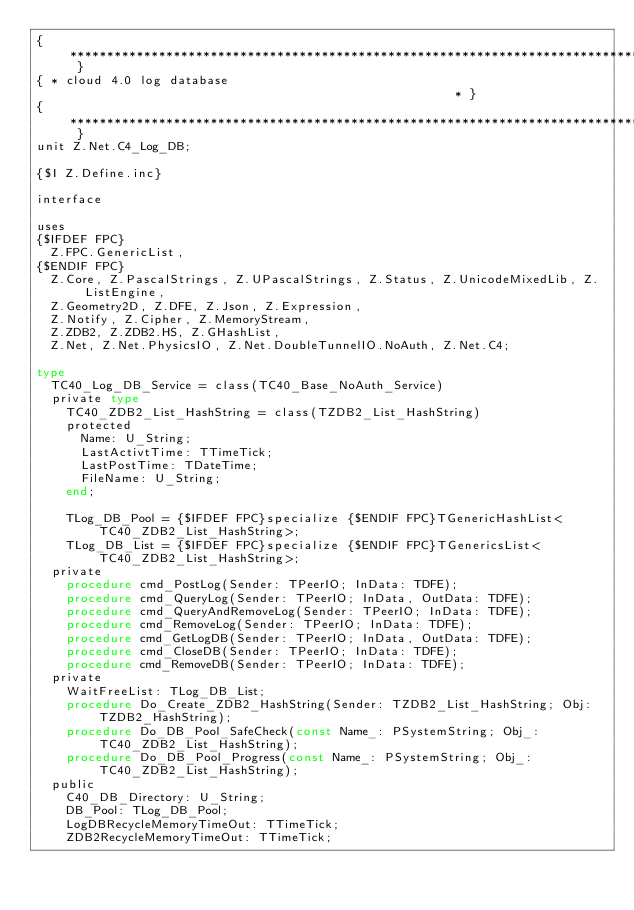Convert code to text. <code><loc_0><loc_0><loc_500><loc_500><_Pascal_>{ ****************************************************************************** }
{ * cloud 4.0 log database                                                     * }
{ ****************************************************************************** }
unit Z.Net.C4_Log_DB;

{$I Z.Define.inc}

interface

uses
{$IFDEF FPC}
  Z.FPC.GenericList,
{$ENDIF FPC}
  Z.Core, Z.PascalStrings, Z.UPascalStrings, Z.Status, Z.UnicodeMixedLib, Z.ListEngine,
  Z.Geometry2D, Z.DFE, Z.Json, Z.Expression,
  Z.Notify, Z.Cipher, Z.MemoryStream,
  Z.ZDB2, Z.ZDB2.HS, Z.GHashList,
  Z.Net, Z.Net.PhysicsIO, Z.Net.DoubleTunnelIO.NoAuth, Z.Net.C4;

type
  TC40_Log_DB_Service = class(TC40_Base_NoAuth_Service)
  private type
    TC40_ZDB2_List_HashString = class(TZDB2_List_HashString)
    protected
      Name: U_String;
      LastActivtTime: TTimeTick;
      LastPostTime: TDateTime;
      FileName: U_String;
    end;

    TLog_DB_Pool = {$IFDEF FPC}specialize {$ENDIF FPC}TGenericHashList<TC40_ZDB2_List_HashString>;
    TLog_DB_List = {$IFDEF FPC}specialize {$ENDIF FPC}TGenericsList<TC40_ZDB2_List_HashString>;
  private
    procedure cmd_PostLog(Sender: TPeerIO; InData: TDFE);
    procedure cmd_QueryLog(Sender: TPeerIO; InData, OutData: TDFE);
    procedure cmd_QueryAndRemoveLog(Sender: TPeerIO; InData: TDFE);
    procedure cmd_RemoveLog(Sender: TPeerIO; InData: TDFE);
    procedure cmd_GetLogDB(Sender: TPeerIO; InData, OutData: TDFE);
    procedure cmd_CloseDB(Sender: TPeerIO; InData: TDFE);
    procedure cmd_RemoveDB(Sender: TPeerIO; InData: TDFE);
  private
    WaitFreeList: TLog_DB_List;
    procedure Do_Create_ZDB2_HashString(Sender: TZDB2_List_HashString; Obj: TZDB2_HashString);
    procedure Do_DB_Pool_SafeCheck(const Name_: PSystemString; Obj_: TC40_ZDB2_List_HashString);
    procedure Do_DB_Pool_Progress(const Name_: PSystemString; Obj_: TC40_ZDB2_List_HashString);
  public
    C40_DB_Directory: U_String;
    DB_Pool: TLog_DB_Pool;
    LogDBRecycleMemoryTimeOut: TTimeTick;
    ZDB2RecycleMemoryTimeOut: TTimeTick;</code> 